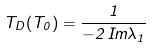<formula> <loc_0><loc_0><loc_500><loc_500>T _ { D } ( T _ { 0 } ) = \frac { 1 } { - 2 \, I m \lambda _ { 1 } }</formula> 